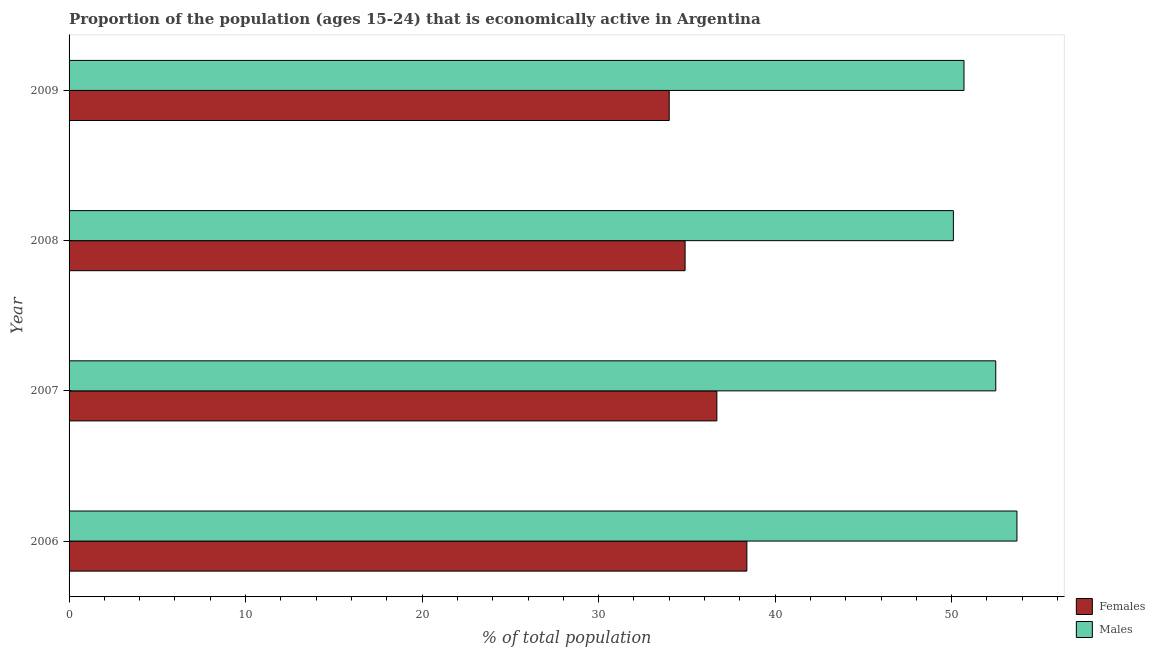How many different coloured bars are there?
Offer a very short reply. 2. How many bars are there on the 2nd tick from the top?
Your answer should be very brief. 2. What is the label of the 2nd group of bars from the top?
Your answer should be very brief. 2008. In how many cases, is the number of bars for a given year not equal to the number of legend labels?
Give a very brief answer. 0. What is the percentage of economically active male population in 2009?
Your response must be concise. 50.7. Across all years, what is the maximum percentage of economically active female population?
Provide a succinct answer. 38.4. Across all years, what is the minimum percentage of economically active male population?
Offer a very short reply. 50.1. In which year was the percentage of economically active male population maximum?
Your response must be concise. 2006. What is the total percentage of economically active male population in the graph?
Your response must be concise. 207. What is the difference between the percentage of economically active male population in 2007 and that in 2009?
Offer a terse response. 1.8. What is the difference between the percentage of economically active male population in 2009 and the percentage of economically active female population in 2006?
Your answer should be compact. 12.3. In the year 2008, what is the difference between the percentage of economically active male population and percentage of economically active female population?
Provide a short and direct response. 15.2. What is the ratio of the percentage of economically active female population in 2008 to that in 2009?
Make the answer very short. 1.03. In how many years, is the percentage of economically active female population greater than the average percentage of economically active female population taken over all years?
Keep it short and to the point. 2. What does the 1st bar from the top in 2007 represents?
Provide a succinct answer. Males. What does the 2nd bar from the bottom in 2006 represents?
Offer a terse response. Males. How many bars are there?
Offer a very short reply. 8. How many years are there in the graph?
Provide a succinct answer. 4. Are the values on the major ticks of X-axis written in scientific E-notation?
Offer a very short reply. No. Does the graph contain any zero values?
Offer a terse response. No. Does the graph contain grids?
Ensure brevity in your answer.  No. Where does the legend appear in the graph?
Make the answer very short. Bottom right. How many legend labels are there?
Keep it short and to the point. 2. What is the title of the graph?
Ensure brevity in your answer.  Proportion of the population (ages 15-24) that is economically active in Argentina. Does "Researchers" appear as one of the legend labels in the graph?
Keep it short and to the point. No. What is the label or title of the X-axis?
Offer a terse response. % of total population. What is the label or title of the Y-axis?
Your answer should be compact. Year. What is the % of total population of Females in 2006?
Give a very brief answer. 38.4. What is the % of total population of Males in 2006?
Make the answer very short. 53.7. What is the % of total population of Females in 2007?
Offer a very short reply. 36.7. What is the % of total population in Males in 2007?
Provide a succinct answer. 52.5. What is the % of total population of Females in 2008?
Keep it short and to the point. 34.9. What is the % of total population in Males in 2008?
Offer a very short reply. 50.1. What is the % of total population of Males in 2009?
Offer a terse response. 50.7. Across all years, what is the maximum % of total population of Females?
Provide a succinct answer. 38.4. Across all years, what is the maximum % of total population in Males?
Offer a very short reply. 53.7. Across all years, what is the minimum % of total population of Females?
Provide a succinct answer. 34. Across all years, what is the minimum % of total population in Males?
Make the answer very short. 50.1. What is the total % of total population of Females in the graph?
Keep it short and to the point. 144. What is the total % of total population in Males in the graph?
Keep it short and to the point. 207. What is the difference between the % of total population of Females in 2006 and that in 2008?
Provide a short and direct response. 3.5. What is the difference between the % of total population of Females in 2006 and that in 2009?
Your answer should be very brief. 4.4. What is the difference between the % of total population of Males in 2006 and that in 2009?
Offer a terse response. 3. What is the difference between the % of total population of Males in 2007 and that in 2008?
Offer a very short reply. 2.4. What is the difference between the % of total population of Males in 2007 and that in 2009?
Your response must be concise. 1.8. What is the difference between the % of total population in Females in 2008 and that in 2009?
Provide a succinct answer. 0.9. What is the difference between the % of total population of Males in 2008 and that in 2009?
Keep it short and to the point. -0.6. What is the difference between the % of total population of Females in 2006 and the % of total population of Males in 2007?
Keep it short and to the point. -14.1. What is the difference between the % of total population in Females in 2006 and the % of total population in Males in 2008?
Ensure brevity in your answer.  -11.7. What is the difference between the % of total population of Females in 2006 and the % of total population of Males in 2009?
Your answer should be compact. -12.3. What is the difference between the % of total population of Females in 2007 and the % of total population of Males in 2009?
Provide a short and direct response. -14. What is the difference between the % of total population of Females in 2008 and the % of total population of Males in 2009?
Ensure brevity in your answer.  -15.8. What is the average % of total population of Males per year?
Make the answer very short. 51.75. In the year 2006, what is the difference between the % of total population in Females and % of total population in Males?
Keep it short and to the point. -15.3. In the year 2007, what is the difference between the % of total population of Females and % of total population of Males?
Ensure brevity in your answer.  -15.8. In the year 2008, what is the difference between the % of total population of Females and % of total population of Males?
Provide a short and direct response. -15.2. In the year 2009, what is the difference between the % of total population in Females and % of total population in Males?
Make the answer very short. -16.7. What is the ratio of the % of total population of Females in 2006 to that in 2007?
Provide a short and direct response. 1.05. What is the ratio of the % of total population of Males in 2006 to that in 2007?
Ensure brevity in your answer.  1.02. What is the ratio of the % of total population in Females in 2006 to that in 2008?
Ensure brevity in your answer.  1.1. What is the ratio of the % of total population in Males in 2006 to that in 2008?
Offer a terse response. 1.07. What is the ratio of the % of total population of Females in 2006 to that in 2009?
Ensure brevity in your answer.  1.13. What is the ratio of the % of total population in Males in 2006 to that in 2009?
Your response must be concise. 1.06. What is the ratio of the % of total population in Females in 2007 to that in 2008?
Offer a terse response. 1.05. What is the ratio of the % of total population of Males in 2007 to that in 2008?
Your answer should be very brief. 1.05. What is the ratio of the % of total population of Females in 2007 to that in 2009?
Your response must be concise. 1.08. What is the ratio of the % of total population in Males in 2007 to that in 2009?
Make the answer very short. 1.04. What is the ratio of the % of total population in Females in 2008 to that in 2009?
Make the answer very short. 1.03. What is the ratio of the % of total population of Males in 2008 to that in 2009?
Provide a short and direct response. 0.99. What is the difference between the highest and the second highest % of total population in Females?
Your response must be concise. 1.7. 